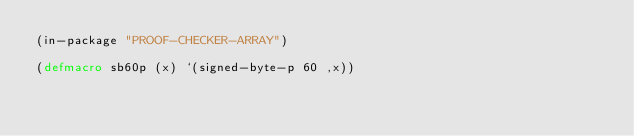<code> <loc_0><loc_0><loc_500><loc_500><_Lisp_>(in-package "PROOF-CHECKER-ARRAY")

(defmacro sb60p (x) `(signed-byte-p 60 ,x))
</code> 